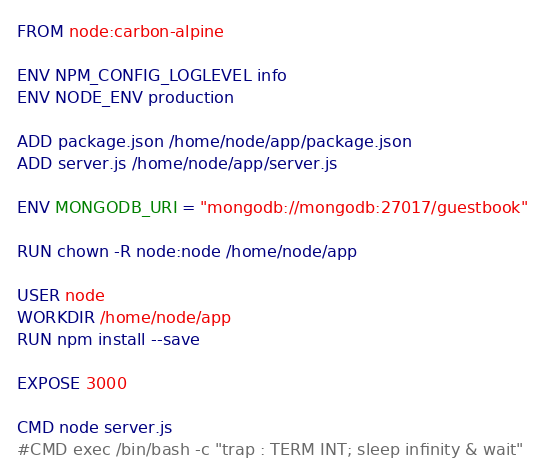<code> <loc_0><loc_0><loc_500><loc_500><_Dockerfile_>FROM node:carbon-alpine

ENV NPM_CONFIG_LOGLEVEL info
ENV NODE_ENV production

ADD package.json /home/node/app/package.json
ADD server.js /home/node/app/server.js

ENV MONGODB_URI = "mongodb://mongodb:27017/guestbook"

RUN chown -R node:node /home/node/app 

USER node
WORKDIR /home/node/app
RUN npm install --save

EXPOSE 3000

CMD node server.js
#CMD exec /bin/bash -c "trap : TERM INT; sleep infinity & wait"
</code> 